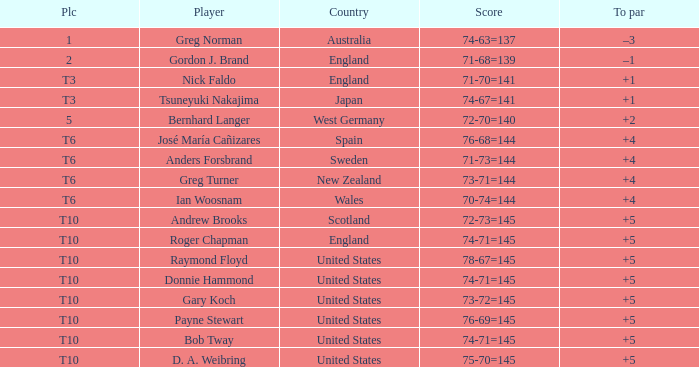What is Greg Norman's place? 1.0. 